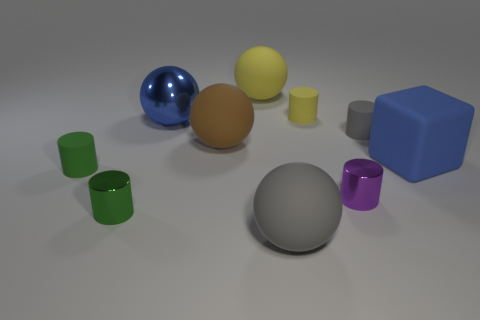What shape is the gray object right of the big sphere that is in front of the small rubber thing in front of the big blue rubber cube?
Offer a terse response. Cylinder. Are there an equal number of brown things that are left of the big yellow rubber thing and gray matte things?
Your answer should be compact. No. Do the green metal cylinder and the yellow ball have the same size?
Offer a very short reply. No. How many matte things are either red cubes or blocks?
Provide a succinct answer. 1. What is the material of the other green cylinder that is the same size as the green metallic cylinder?
Your response must be concise. Rubber. What number of other things are made of the same material as the big brown thing?
Ensure brevity in your answer.  6. Is the number of purple things in front of the green metal object less than the number of purple metallic blocks?
Provide a short and direct response. No. Does the tiny gray matte thing have the same shape as the tiny yellow matte thing?
Your answer should be compact. Yes. There is a gray rubber object in front of the small cylinder to the left of the small metallic cylinder that is to the left of the gray ball; what size is it?
Give a very brief answer. Large. There is a gray thing that is the same shape as the small purple metallic thing; what is it made of?
Provide a short and direct response. Rubber. 